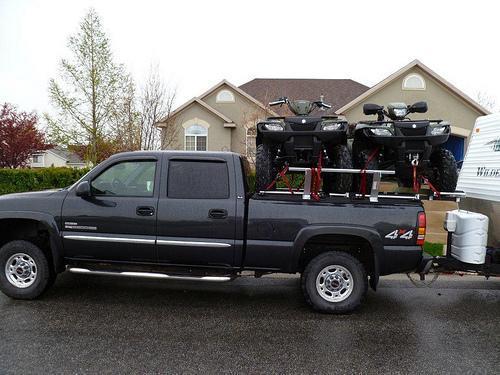How many trucks?
Give a very brief answer. 1. 